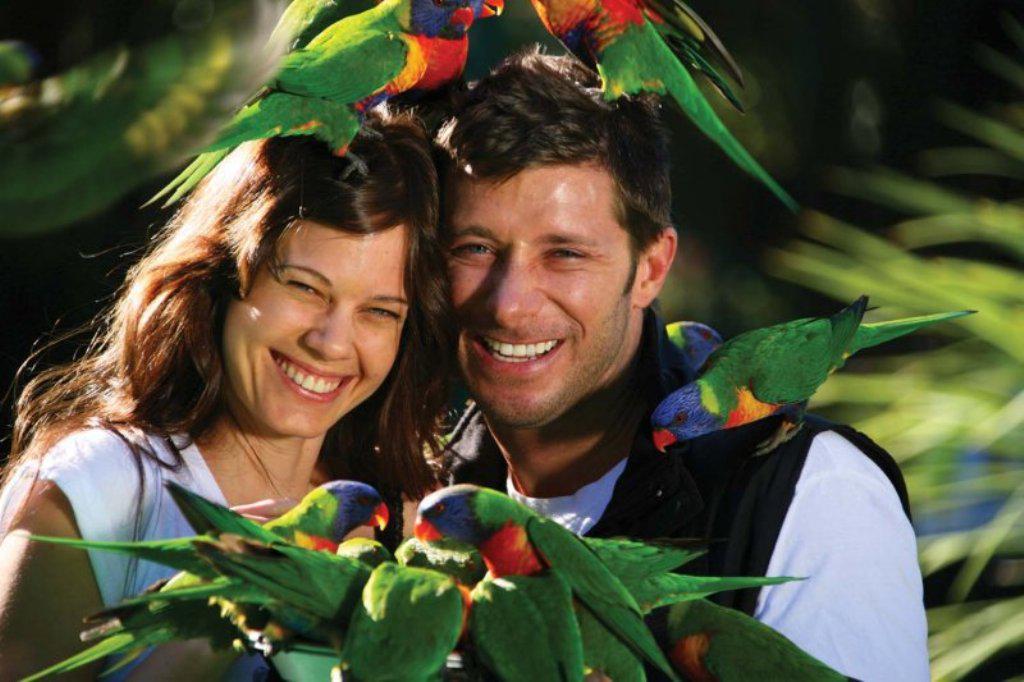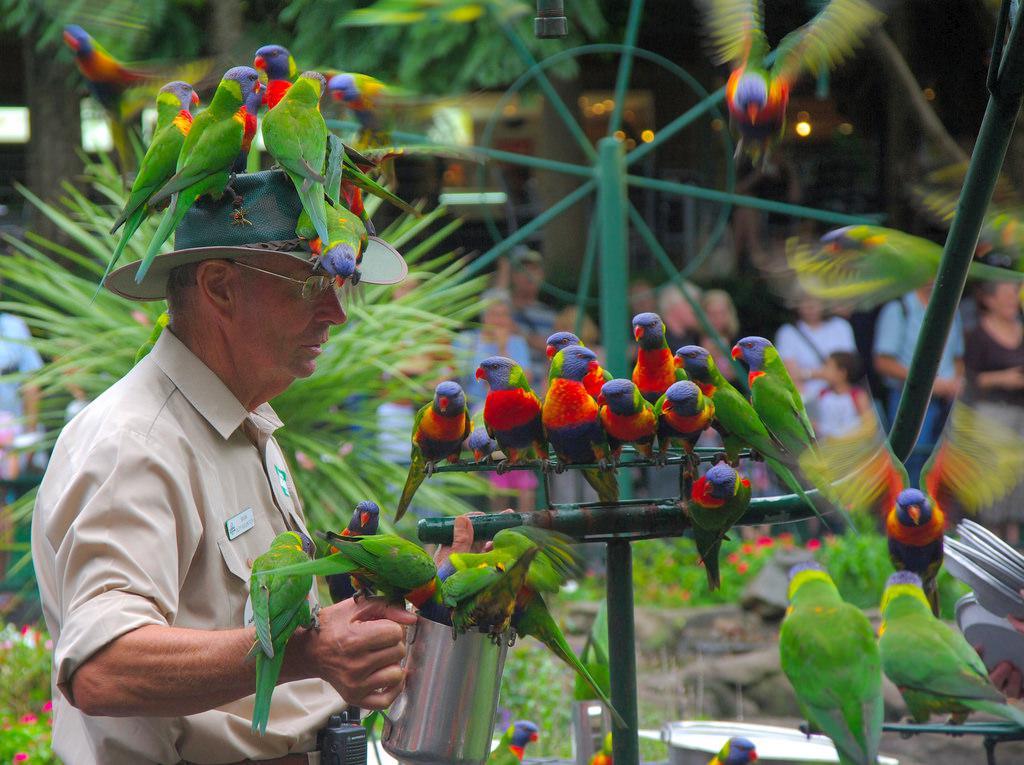The first image is the image on the left, the second image is the image on the right. Examine the images to the left and right. Is the description "There is one human feeding birds in every image." accurate? Answer yes or no. No. The first image is the image on the left, the second image is the image on the right. Examine the images to the left and right. Is the description "Birds are perched on a male in the image on the right and at least one female in the image on the left." accurate? Answer yes or no. Yes. 